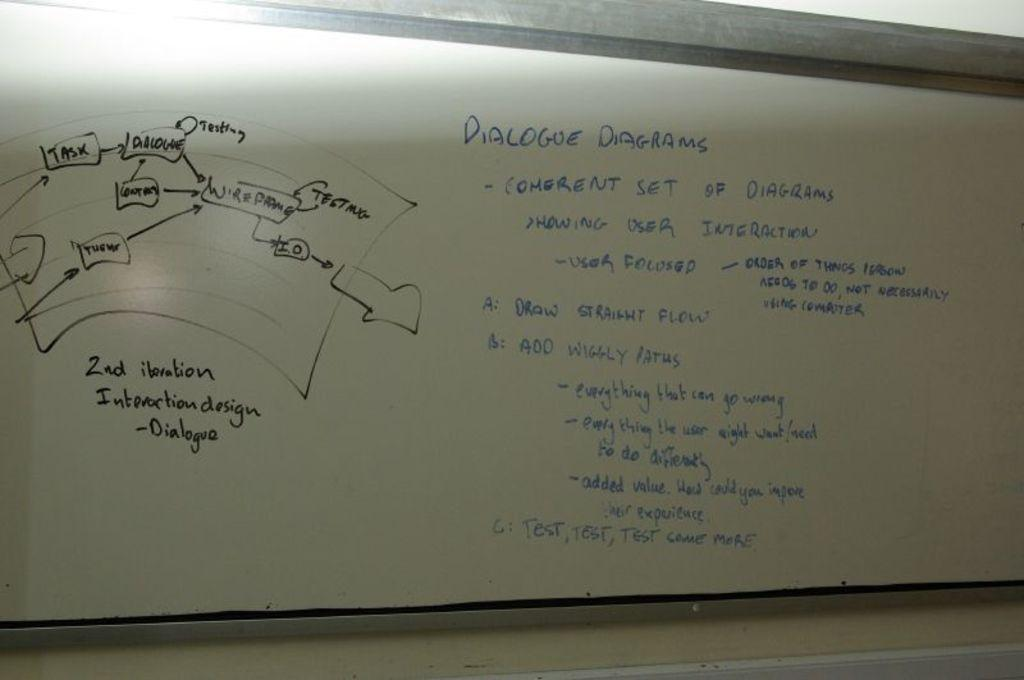Provide a one-sentence caption for the provided image. A whiteboard with information and diagrams about dialogue diagrams. 